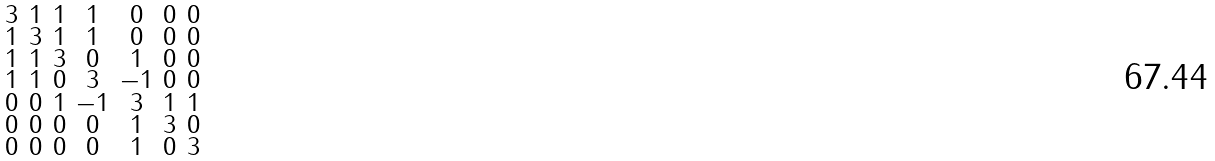<formula> <loc_0><loc_0><loc_500><loc_500>\begin{smallmatrix} 3 & 1 & 1 & 1 & 0 & 0 & 0 \\ 1 & 3 & 1 & 1 & 0 & 0 & 0 \\ 1 & 1 & 3 & 0 & 1 & 0 & 0 \\ 1 & 1 & 0 & 3 & - 1 & 0 & 0 \\ 0 & 0 & 1 & - 1 & 3 & 1 & 1 \\ 0 & 0 & 0 & 0 & 1 & 3 & 0 \\ 0 & 0 & 0 & 0 & 1 & 0 & 3 \end{smallmatrix}</formula> 